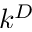Convert formula to latex. <formula><loc_0><loc_0><loc_500><loc_500>k ^ { D }</formula> 